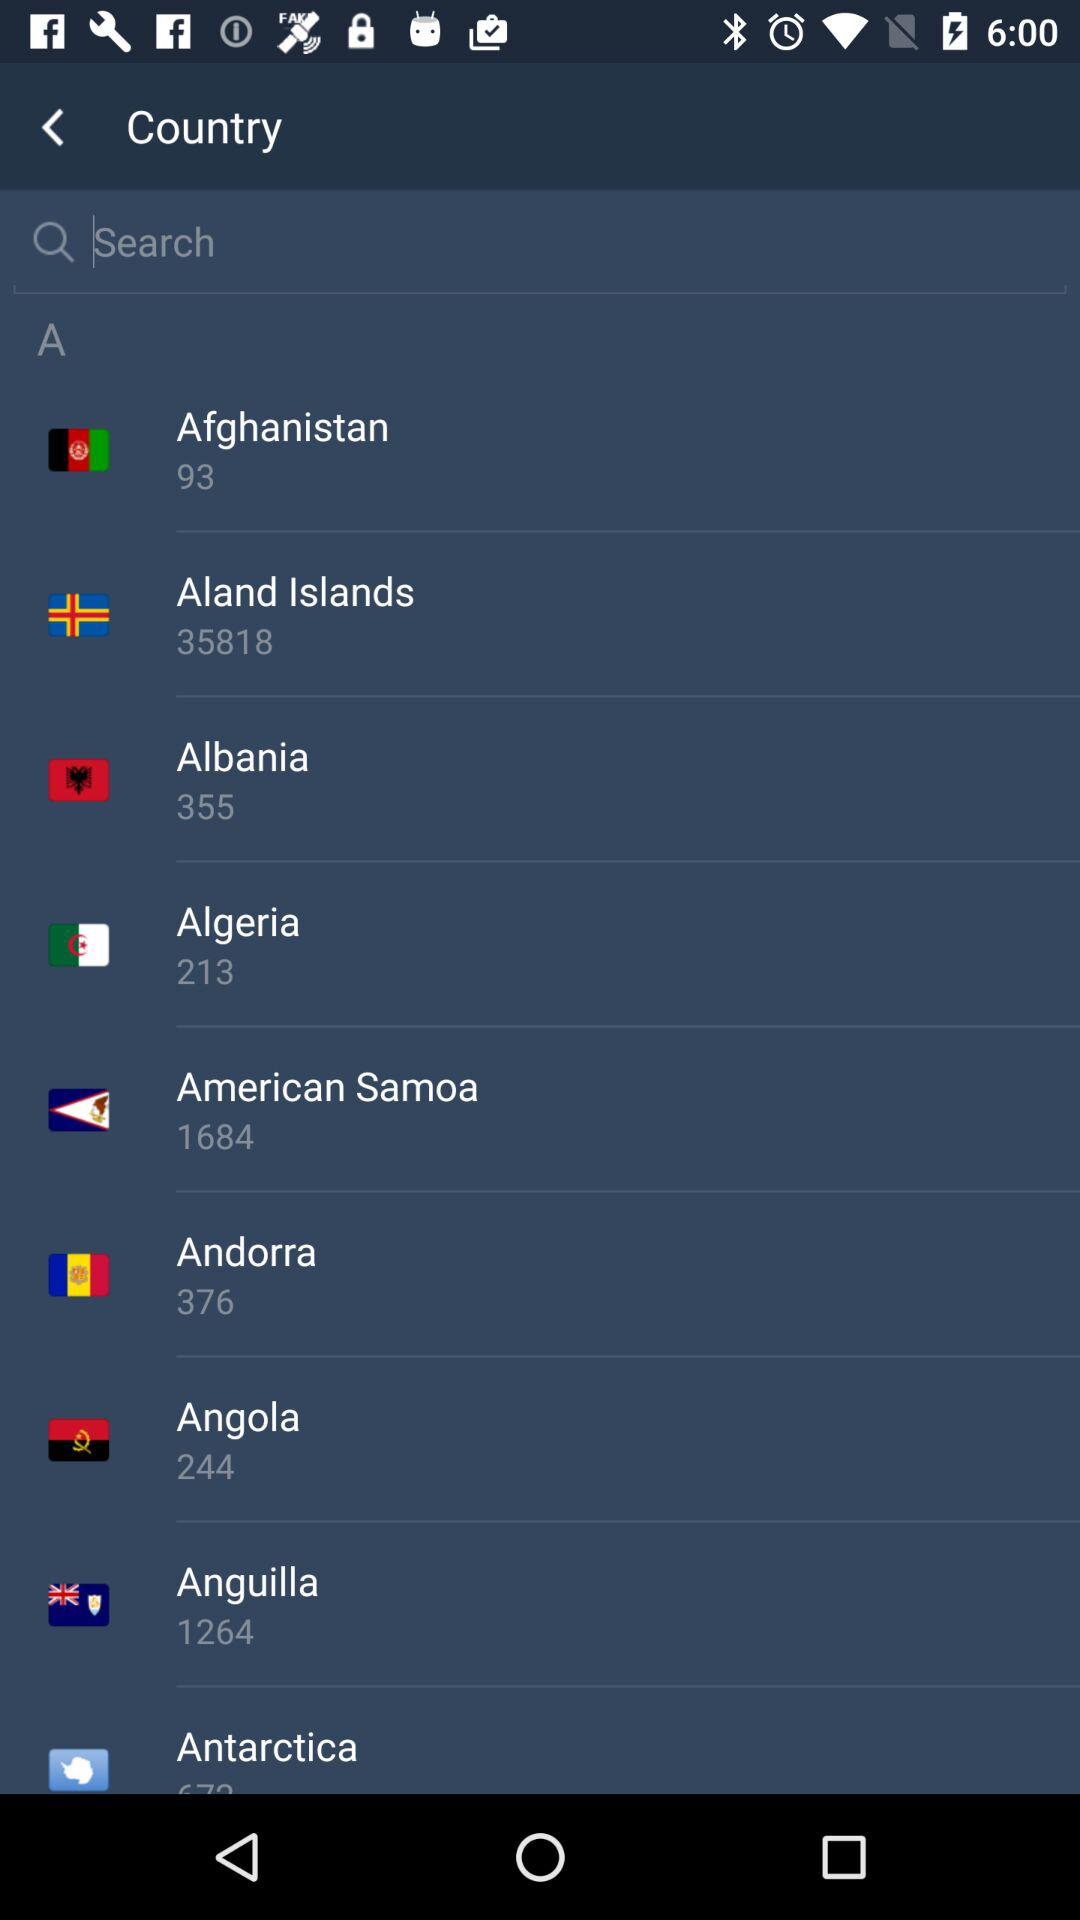What is the country code for Afghanistan? The country code for Afghanistan is 93. 